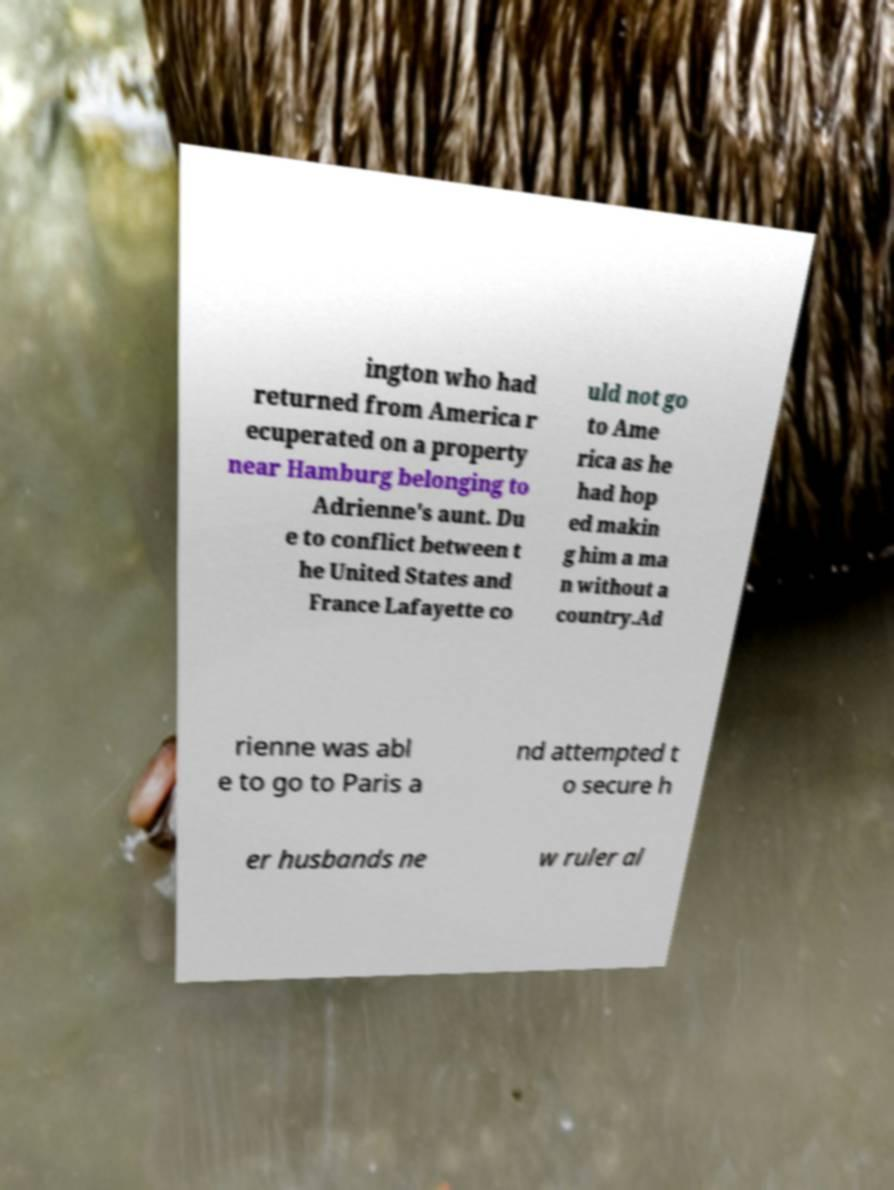I need the written content from this picture converted into text. Can you do that? ington who had returned from America r ecuperated on a property near Hamburg belonging to Adrienne's aunt. Du e to conflict between t he United States and France Lafayette co uld not go to Ame rica as he had hop ed makin g him a ma n without a country.Ad rienne was abl e to go to Paris a nd attempted t o secure h er husbands ne w ruler al 